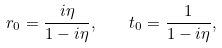Convert formula to latex. <formula><loc_0><loc_0><loc_500><loc_500>r _ { 0 } = \frac { i \eta } { 1 - i \eta } , \quad t _ { 0 } = \frac { 1 } { 1 - i \eta } ,</formula> 